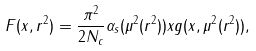Convert formula to latex. <formula><loc_0><loc_0><loc_500><loc_500>F ( x , r ^ { 2 } ) = \frac { \pi ^ { 2 } } { 2 { N _ { c } } } { \alpha _ { s } } ( \mu ^ { 2 } ( r ^ { 2 } ) ) x g ( x , \mu ^ { 2 } ( r ^ { 2 } ) ) ,</formula> 